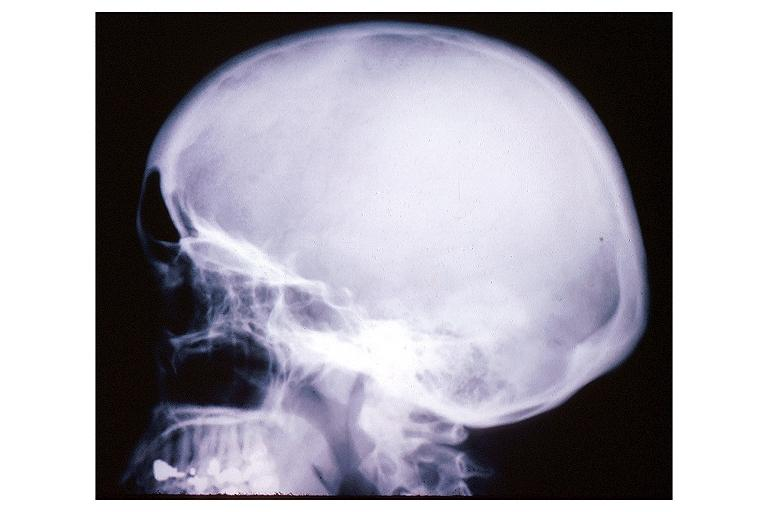does this fixed tissue show pagets disease?
Answer the question using a single word or phrase. No 